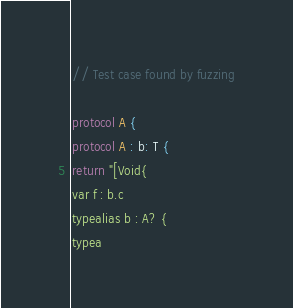<code> <loc_0><loc_0><loc_500><loc_500><_Swift_>// Test case found by fuzzing

protocol A {
protocol A : b: T {
return "[Void{
var f : b.c
typealias b : A? {
typea
</code> 